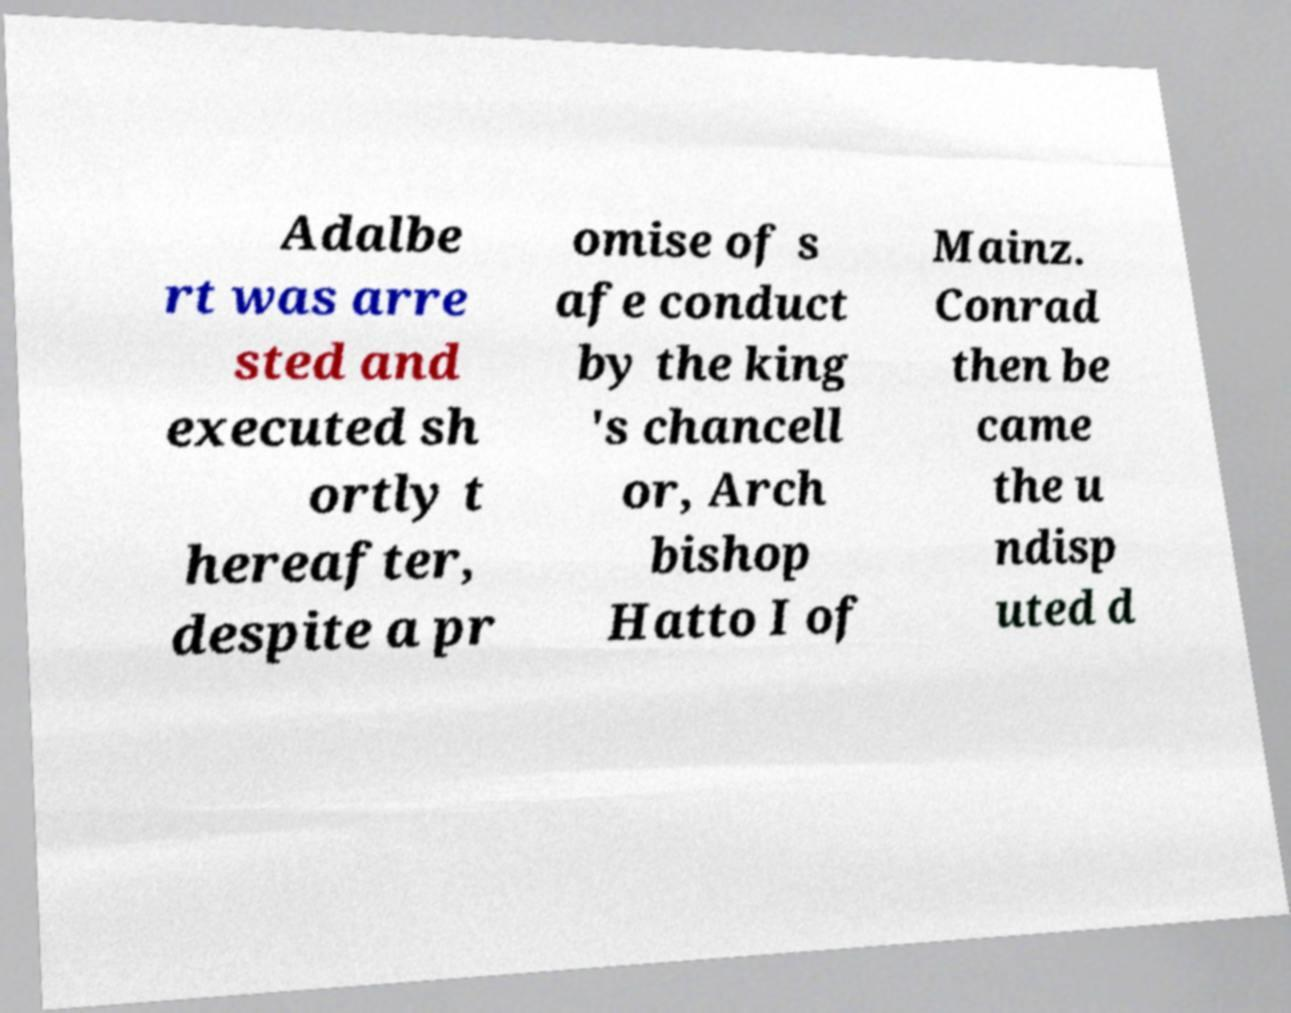There's text embedded in this image that I need extracted. Can you transcribe it verbatim? Adalbe rt was arre sted and executed sh ortly t hereafter, despite a pr omise of s afe conduct by the king 's chancell or, Arch bishop Hatto I of Mainz. Conrad then be came the u ndisp uted d 